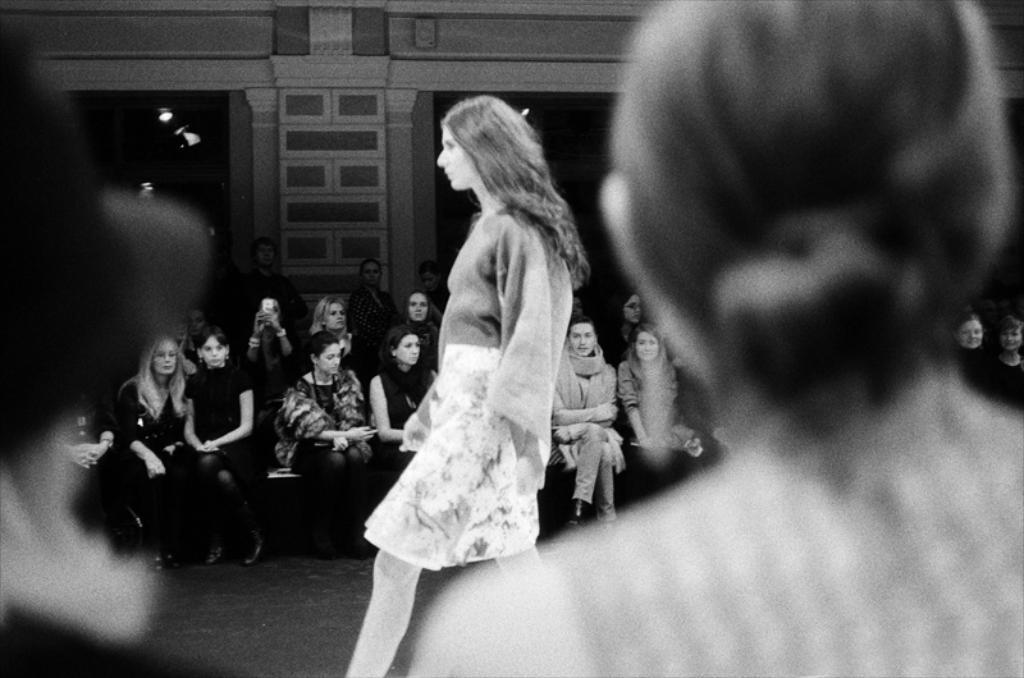What is the woman in the image doing? The woman is walking in the image. What are the people in the background of the image doing? The people in the background are sitting. Can you identify any objects being held by someone in the image? Yes, one person is holding a camera. What type of structure can be seen in the image? There is a building visible in the image. What can be seen illuminating the scene in the image? Lights are present in the image. What type of bun is being used to hold the snakes in the image? There are no buns or snakes present in the image. Can you describe the pen that the person is using to write in the image? There is no pen or writing activity depicted in the image. 